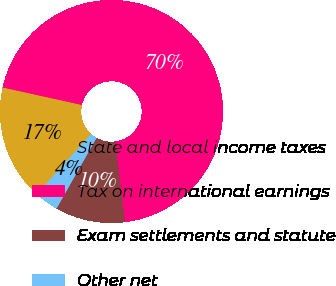Convert chart. <chart><loc_0><loc_0><loc_500><loc_500><pie_chart><fcel>State and local income taxes<fcel>Tax on international earnings<fcel>Exam settlements and statute<fcel>Other net<nl><fcel>16.74%<fcel>69.6%<fcel>10.13%<fcel>3.52%<nl></chart> 